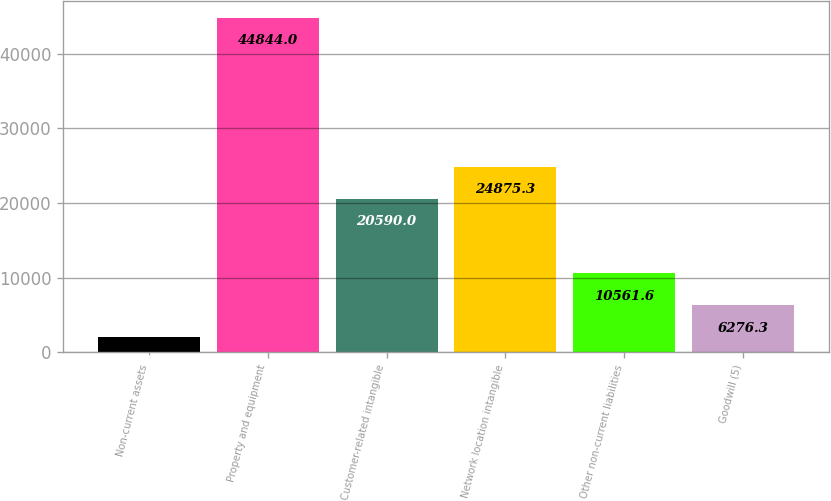Convert chart. <chart><loc_0><loc_0><loc_500><loc_500><bar_chart><fcel>Non-current assets<fcel>Property and equipment<fcel>Customer-related intangible<fcel>Network location intangible<fcel>Other non-current liabilities<fcel>Goodwill (5)<nl><fcel>1991<fcel>44844<fcel>20590<fcel>24875.3<fcel>10561.6<fcel>6276.3<nl></chart> 